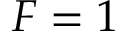Convert formula to latex. <formula><loc_0><loc_0><loc_500><loc_500>F = 1</formula> 